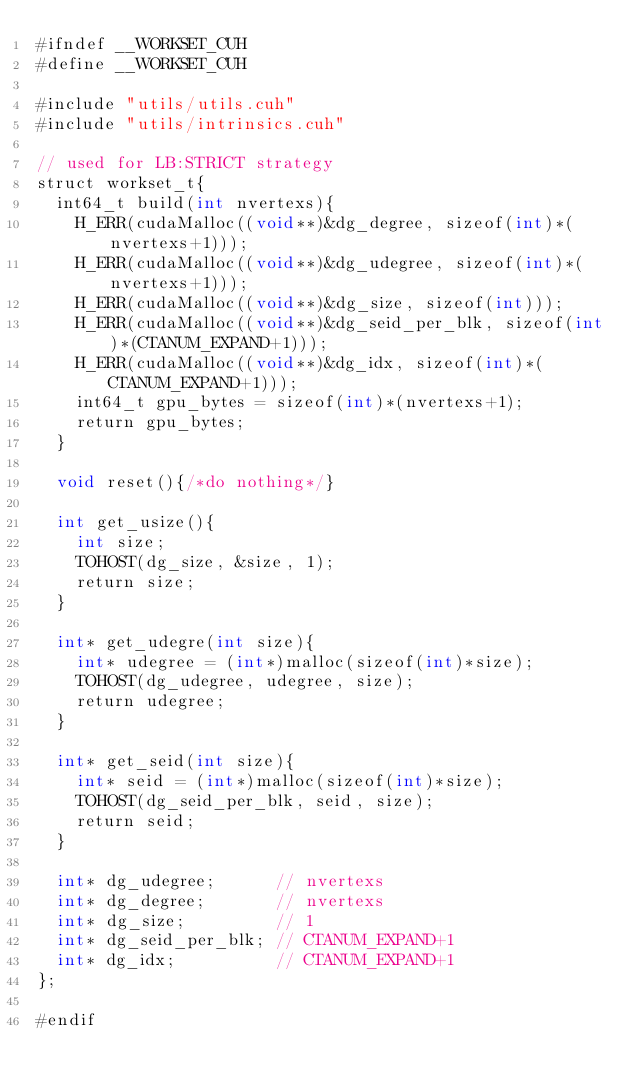Convert code to text. <code><loc_0><loc_0><loc_500><loc_500><_Cuda_>#ifndef __WORKSET_CUH
#define __WORKSET_CUH

#include "utils/utils.cuh"
#include "utils/intrinsics.cuh"

// used for LB:STRICT strategy
struct workset_t{
  int64_t build(int nvertexs){
    H_ERR(cudaMalloc((void**)&dg_degree, sizeof(int)*(nvertexs+1)));
    H_ERR(cudaMalloc((void**)&dg_udegree, sizeof(int)*(nvertexs+1)));
    H_ERR(cudaMalloc((void**)&dg_size, sizeof(int)));
    H_ERR(cudaMalloc((void**)&dg_seid_per_blk, sizeof(int)*(CTANUM_EXPAND+1)));
    H_ERR(cudaMalloc((void**)&dg_idx, sizeof(int)*(CTANUM_EXPAND+1)));
    int64_t gpu_bytes = sizeof(int)*(nvertexs+1); 
    return gpu_bytes;
  }

  void reset(){/*do nothing*/}

  int get_usize(){
    int size;
    TOHOST(dg_size, &size, 1);
    return size;
  }

  int* get_udegre(int size){
    int* udegree = (int*)malloc(sizeof(int)*size);
    TOHOST(dg_udegree, udegree, size);
    return udegree;
  }

  int* get_seid(int size){
    int* seid = (int*)malloc(sizeof(int)*size);
    TOHOST(dg_seid_per_blk, seid, size);
    return seid;
  }

  int* dg_udegree;      // nvertexs
  int* dg_degree;       // nvertexs  
  int* dg_size;         // 1
  int* dg_seid_per_blk; // CTANUM_EXPAND+1
  int* dg_idx;          // CTANUM_EXPAND+1
};

#endif
</code> 